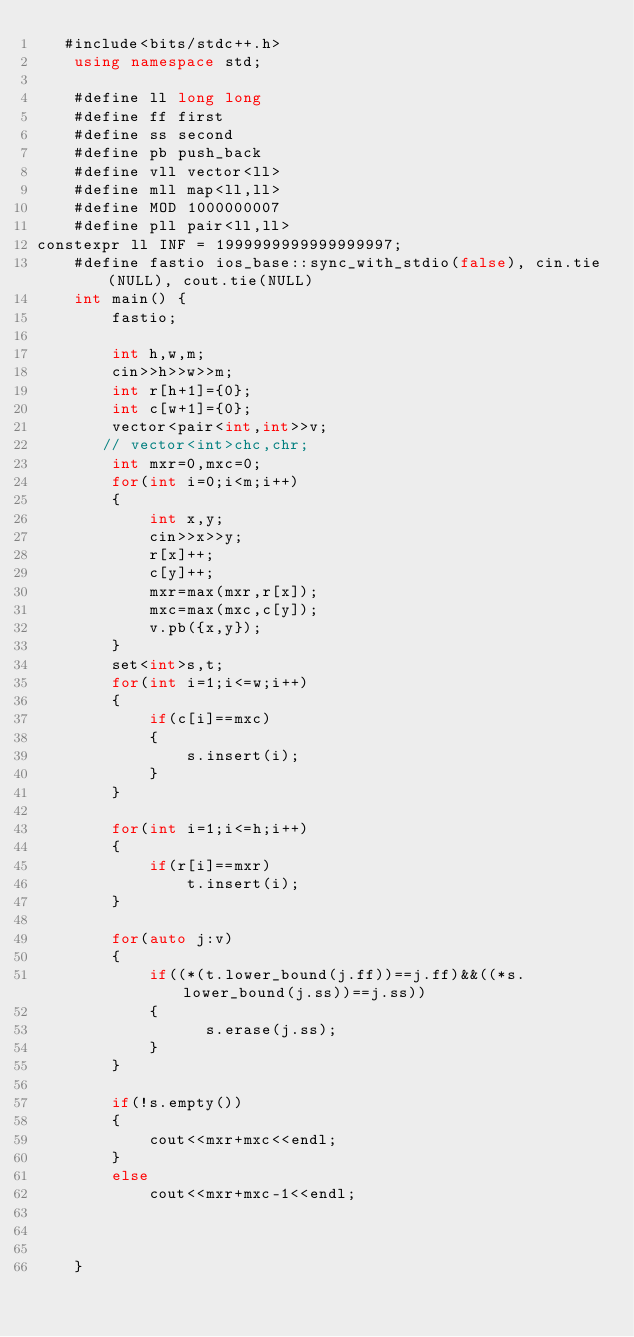Convert code to text. <code><loc_0><loc_0><loc_500><loc_500><_C++_>   #include<bits/stdc++.h>
    using namespace std;

    #define ll long long
    #define ff first
    #define ss second
    #define pb push_back
    #define vll vector<ll>
    #define mll map<ll,ll>
    #define MOD 1000000007
    #define pll pair<ll,ll>
constexpr ll INF = 1999999999999999997; 
    #define fastio ios_base::sync_with_stdio(false), cin.tie(NULL), cout.tie(NULL)
    int main() {
        fastio;

        int h,w,m;
        cin>>h>>w>>m;
        int r[h+1]={0};
        int c[w+1]={0};
        vector<pair<int,int>>v;
       // vector<int>chc,chr;
        int mxr=0,mxc=0;
        for(int i=0;i<m;i++)
        {
            int x,y;
            cin>>x>>y;
            r[x]++;
            c[y]++;
            mxr=max(mxr,r[x]);
            mxc=max(mxc,c[y]);
            v.pb({x,y});
        }
        set<int>s,t;
        for(int i=1;i<=w;i++)
        {
            if(c[i]==mxc)
            {
                s.insert(i);
            }
        }

        for(int i=1;i<=h;i++)
        {
            if(r[i]==mxr)
                t.insert(i);
        }

        for(auto j:v)
        {
            if((*(t.lower_bound(j.ff))==j.ff)&&((*s.lower_bound(j.ss))==j.ss))
            {
                  s.erase(j.ss);
            }
        }

        if(!s.empty())
        {
            cout<<mxr+mxc<<endl;
        }
        else
            cout<<mxr+mxc-1<<endl;       

    

    }</code> 